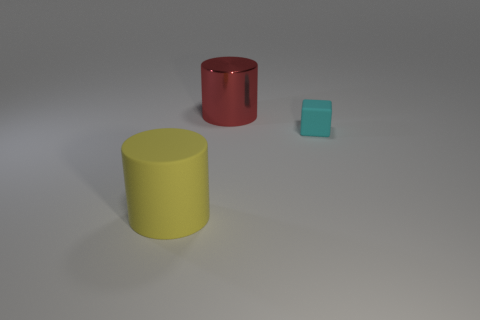Is there any other thing that is made of the same material as the large red object?
Your answer should be compact. No. Are the large cylinder in front of the matte cube and the red cylinder made of the same material?
Ensure brevity in your answer.  No. What number of small things are either matte blocks or yellow matte cylinders?
Make the answer very short. 1. How big is the red metal object?
Offer a terse response. Large. There is a red cylinder; is it the same size as the rubber thing that is in front of the small cyan object?
Ensure brevity in your answer.  Yes. How many blue objects are shiny cylinders or big matte cylinders?
Your response must be concise. 0. What number of large metal balls are there?
Offer a very short reply. 0. There is a object behind the cyan matte thing; how big is it?
Keep it short and to the point. Large. Is the size of the red thing the same as the cyan rubber object?
Your response must be concise. No. What number of things are either rubber cubes or rubber objects behind the yellow object?
Your answer should be very brief. 1. 